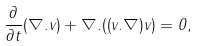<formula> <loc_0><loc_0><loc_500><loc_500>\frac { \partial } { \partial t } ( \nabla . { v } ) + \nabla . ( ( { v } . { \nabla } ) { v } ) = 0 ,</formula> 